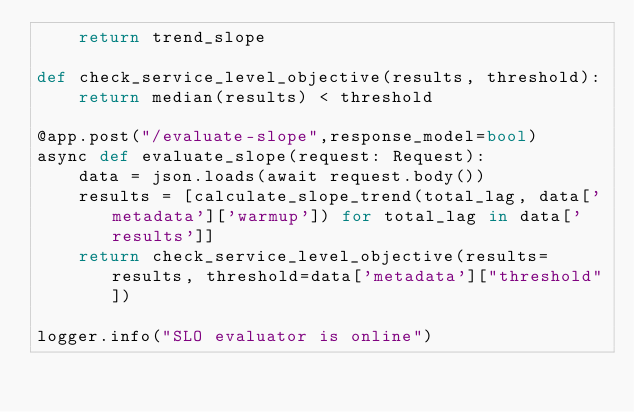Convert code to text. <code><loc_0><loc_0><loc_500><loc_500><_Python_>    return trend_slope

def check_service_level_objective(results, threshold):
    return median(results) < threshold

@app.post("/evaluate-slope",response_model=bool)
async def evaluate_slope(request: Request):
    data = json.loads(await request.body())
    results = [calculate_slope_trend(total_lag, data['metadata']['warmup']) for total_lag in data['results']]
    return check_service_level_objective(results=results, threshold=data['metadata']["threshold"])

logger.info("SLO evaluator is online")</code> 